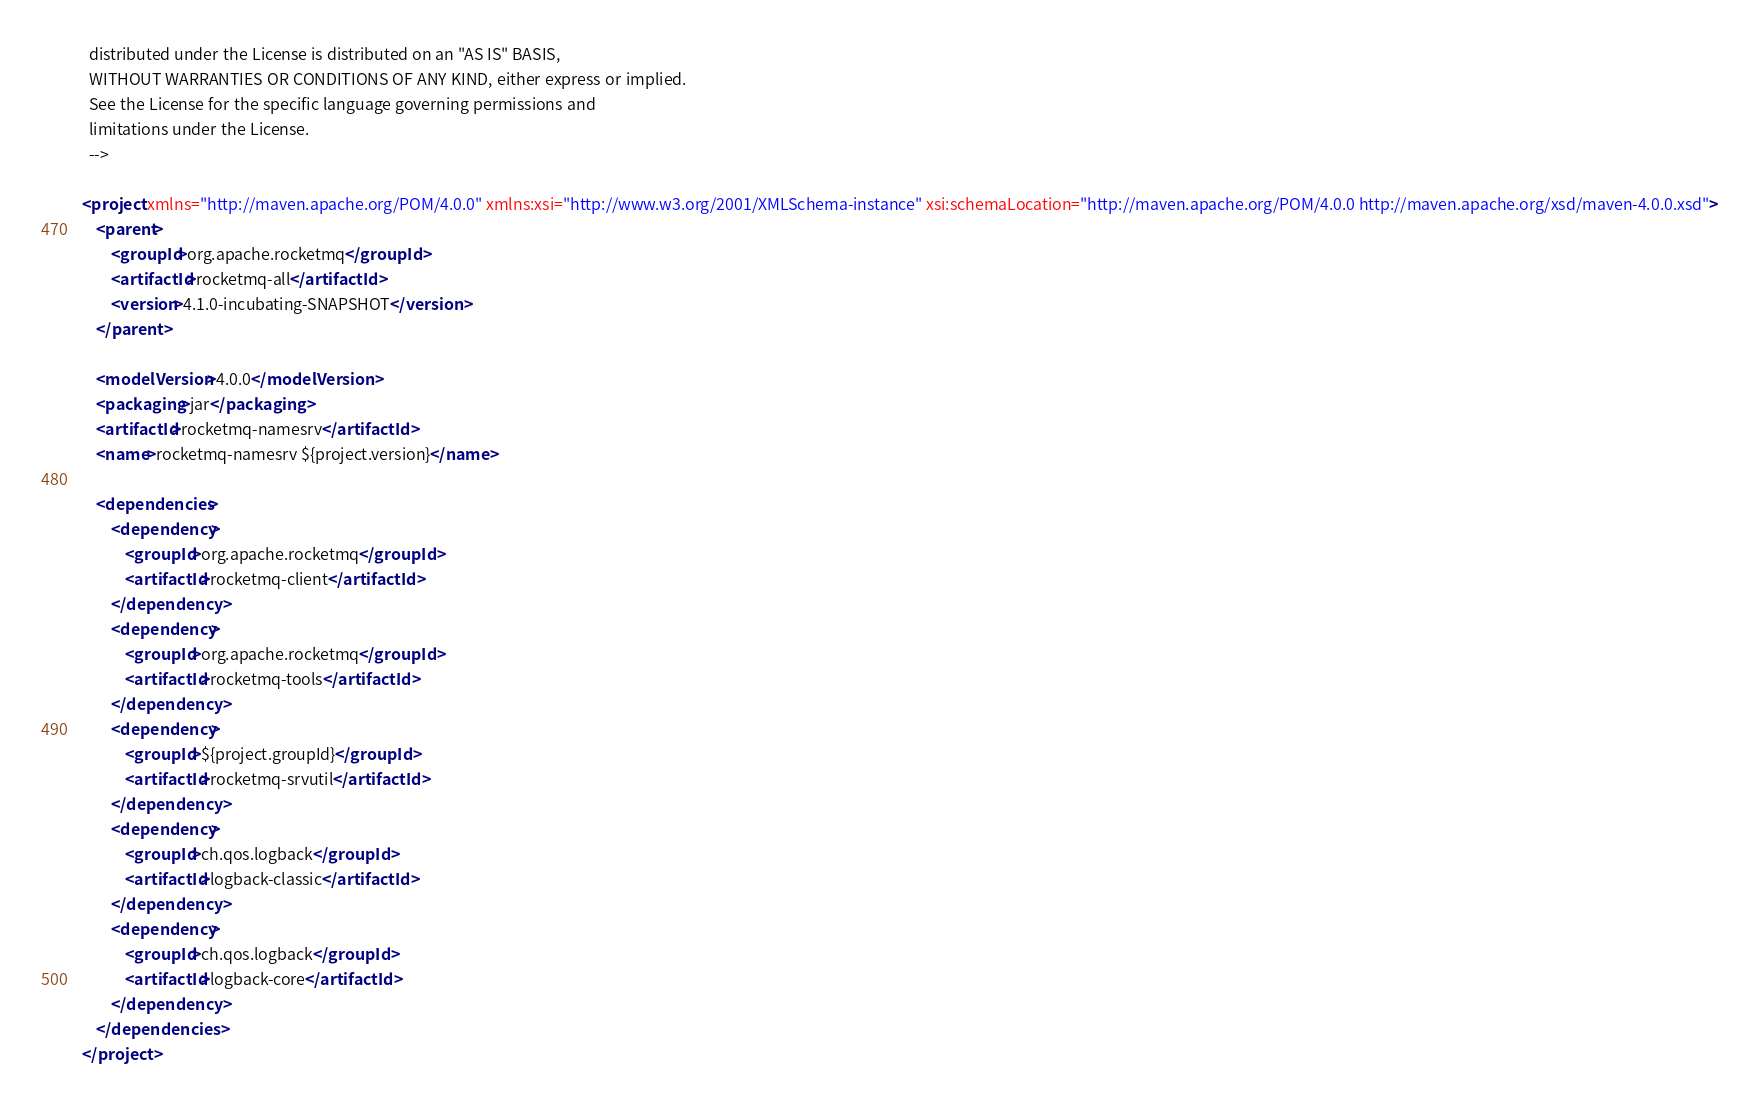<code> <loc_0><loc_0><loc_500><loc_500><_XML_>  distributed under the License is distributed on an "AS IS" BASIS,
  WITHOUT WARRANTIES OR CONDITIONS OF ANY KIND, either express or implied.
  See the License for the specific language governing permissions and
  limitations under the License.
  -->

<project xmlns="http://maven.apache.org/POM/4.0.0" xmlns:xsi="http://www.w3.org/2001/XMLSchema-instance" xsi:schemaLocation="http://maven.apache.org/POM/4.0.0 http://maven.apache.org/xsd/maven-4.0.0.xsd">
    <parent>
        <groupId>org.apache.rocketmq</groupId>
        <artifactId>rocketmq-all</artifactId>
        <version>4.1.0-incubating-SNAPSHOT</version>
    </parent>

    <modelVersion>4.0.0</modelVersion>
    <packaging>jar</packaging>
    <artifactId>rocketmq-namesrv</artifactId>
    <name>rocketmq-namesrv ${project.version}</name>

    <dependencies>
        <dependency>
            <groupId>org.apache.rocketmq</groupId>
            <artifactId>rocketmq-client</artifactId>
        </dependency>
        <dependency>
            <groupId>org.apache.rocketmq</groupId>
            <artifactId>rocketmq-tools</artifactId>
        </dependency>
        <dependency>
            <groupId>${project.groupId}</groupId>
            <artifactId>rocketmq-srvutil</artifactId>
        </dependency>
        <dependency>
            <groupId>ch.qos.logback</groupId>
            <artifactId>logback-classic</artifactId>
        </dependency>
        <dependency>
            <groupId>ch.qos.logback</groupId>
            <artifactId>logback-core</artifactId>
        </dependency>
    </dependencies>
</project>
</code> 